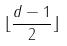Convert formula to latex. <formula><loc_0><loc_0><loc_500><loc_500>\lfloor \frac { d - 1 } { 2 } \rfloor</formula> 